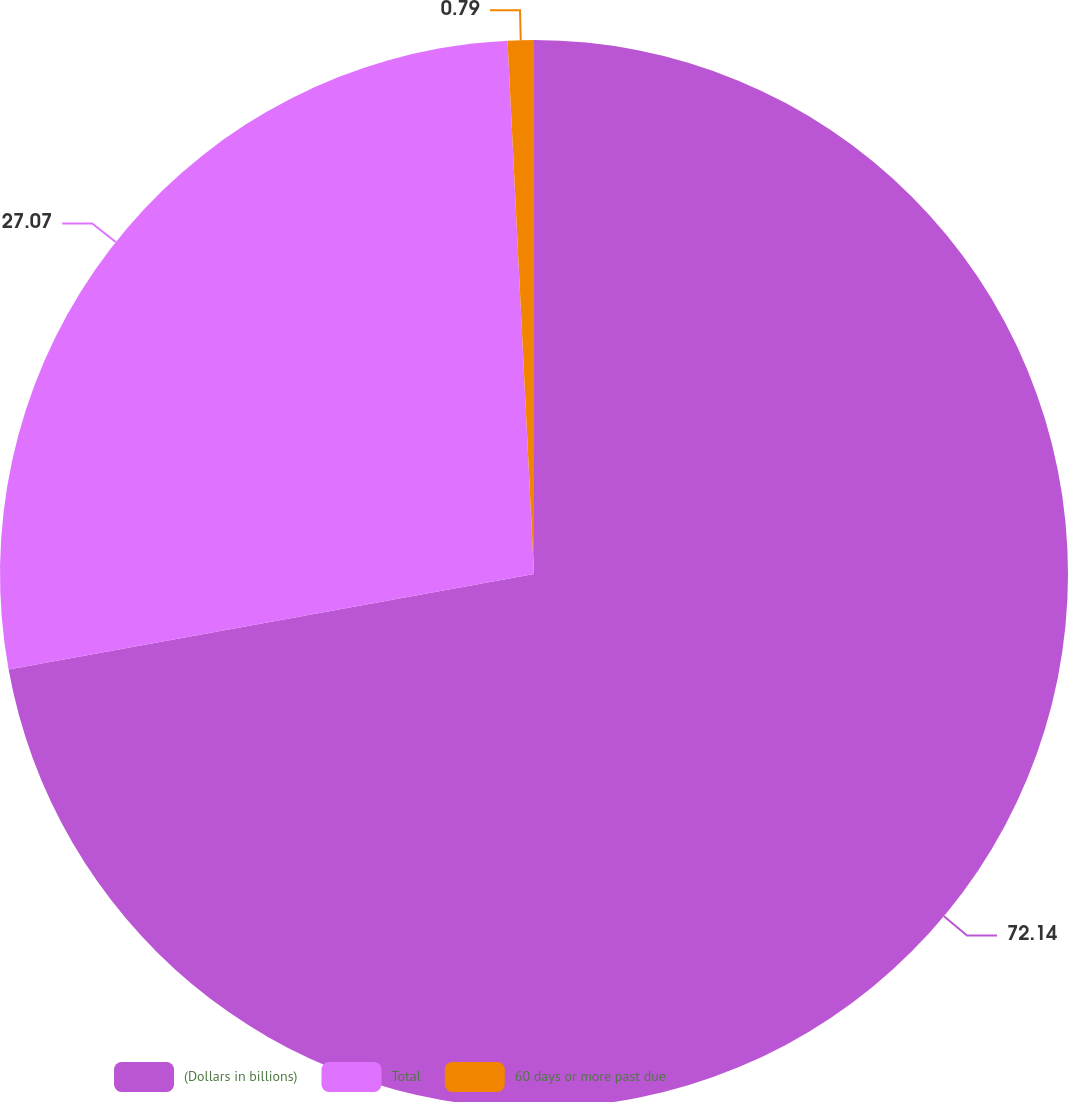Convert chart to OTSL. <chart><loc_0><loc_0><loc_500><loc_500><pie_chart><fcel>(Dollars in billions)<fcel>Total<fcel>60 days or more past due<nl><fcel>72.14%<fcel>27.07%<fcel>0.79%<nl></chart> 